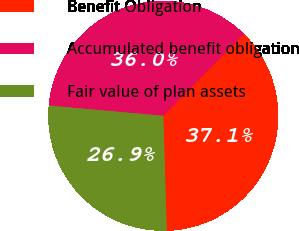Convert chart. <chart><loc_0><loc_0><loc_500><loc_500><pie_chart><fcel>Benefit Obligation<fcel>Accumulated benefit obligation<fcel>Fair value of plan assets<nl><fcel>37.14%<fcel>35.95%<fcel>26.91%<nl></chart> 